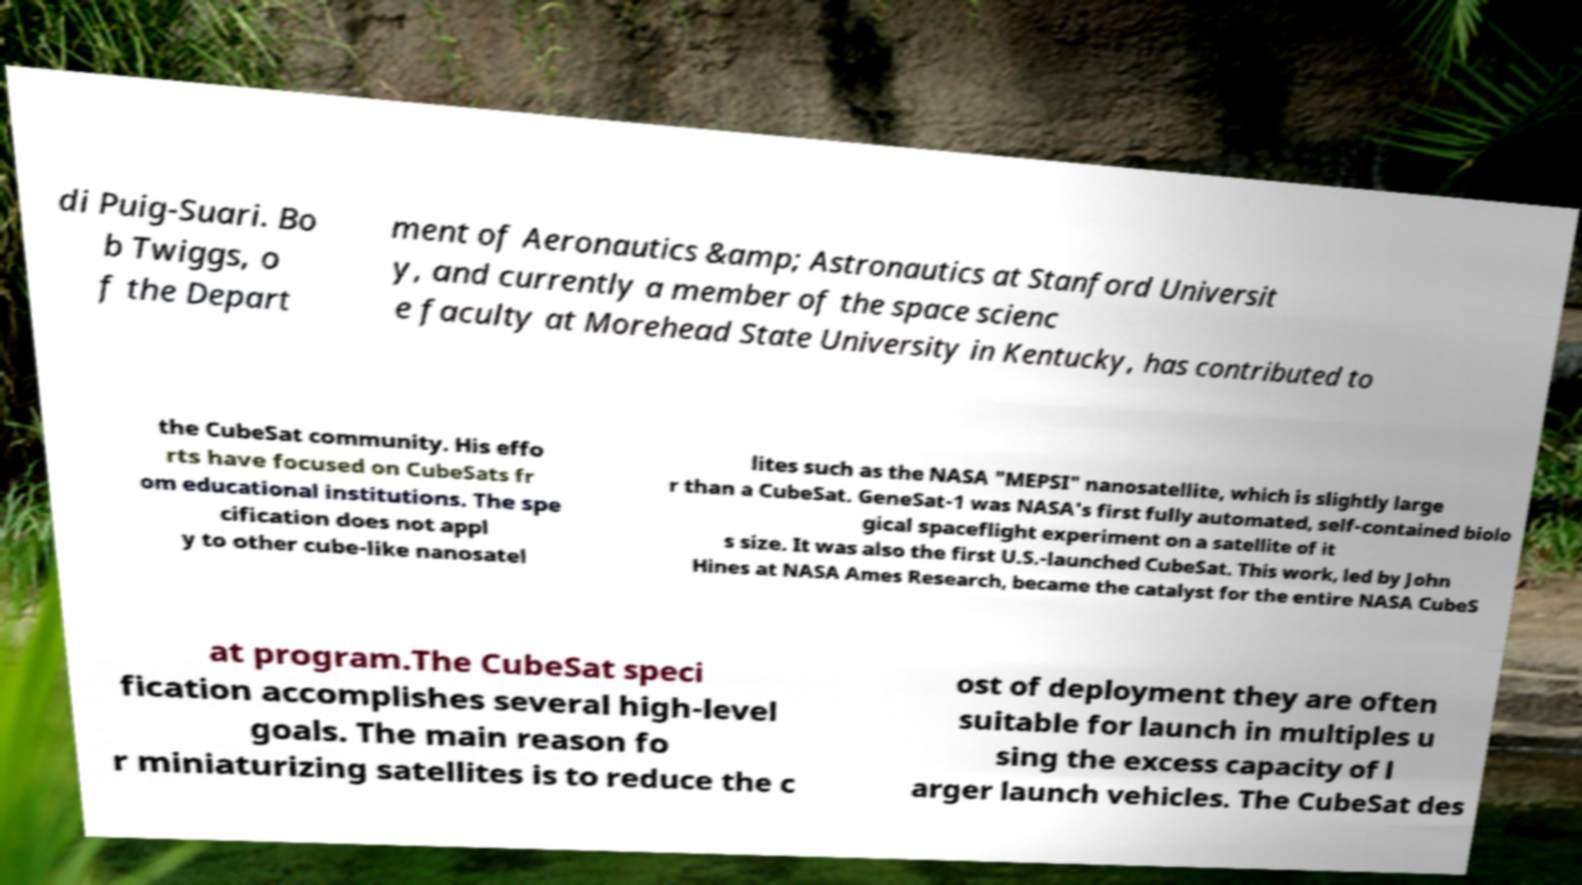Could you extract and type out the text from this image? di Puig-Suari. Bo b Twiggs, o f the Depart ment of Aeronautics &amp; Astronautics at Stanford Universit y, and currently a member of the space scienc e faculty at Morehead State University in Kentucky, has contributed to the CubeSat community. His effo rts have focused on CubeSats fr om educational institutions. The spe cification does not appl y to other cube-like nanosatel lites such as the NASA "MEPSI" nanosatellite, which is slightly large r than a CubeSat. GeneSat-1 was NASA's first fully automated, self-contained biolo gical spaceflight experiment on a satellite of it s size. It was also the first U.S.-launched CubeSat. This work, led by John Hines at NASA Ames Research, became the catalyst for the entire NASA CubeS at program.The CubeSat speci fication accomplishes several high-level goals. The main reason fo r miniaturizing satellites is to reduce the c ost of deployment they are often suitable for launch in multiples u sing the excess capacity of l arger launch vehicles. The CubeSat des 